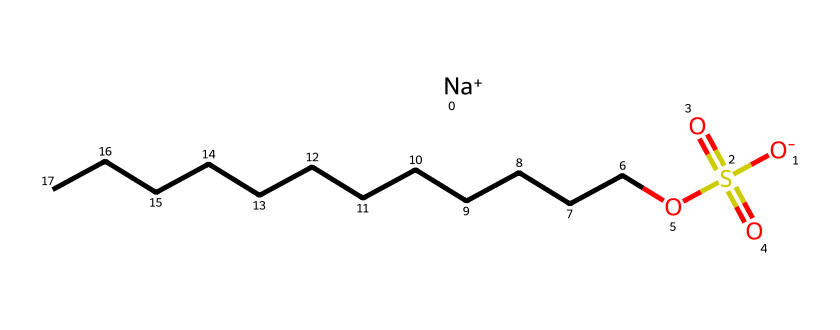What is the total number of carbon atoms in sodium dodecyl sulfate? The molecule contains a straight-chain hydrocarbon tail, indicated by "CCCCCCCCCCCC," which consists of 12 carbon atoms.
Answer: 12 What functional groups are present in sodium dodecyl sulfate? The compound features a sulfate group (–SO4) and a carboxylate group (–COO-), as indicated by the presence of the sulfur and oxygen atoms bonded in a specific manner, along with the sodium ion (Na+).
Answer: sulfate, carboxylate How many oxygen atoms are in the chemical structure of sodium dodecyl sulfate? Upon examining the structure, there are a total of 4 oxygen atoms: 3 from the sulfate group and 1 from the carboxylate.
Answer: 4 What is the charge of the sodium ion in this structure? The sodium ion is indicated as "Na+" in the SMILES representation, which signifies that it has a positive charge.
Answer: positive What type of surfactant is sodium dodecyl sulfate classified as? Due to the presence of both hydrophilic (the sulfate group) and hydrophobic (the dodecyl chain) components, it is classified as anionic surfactant.
Answer: anionic What property allows sodium dodecyl sulfate to act as an emulsifier? The amphiphilic nature of the molecule, created by its hydrophobic tail and hydrophilic head, facilitates the mixing of oil and water.
Answer: amphiphilic 